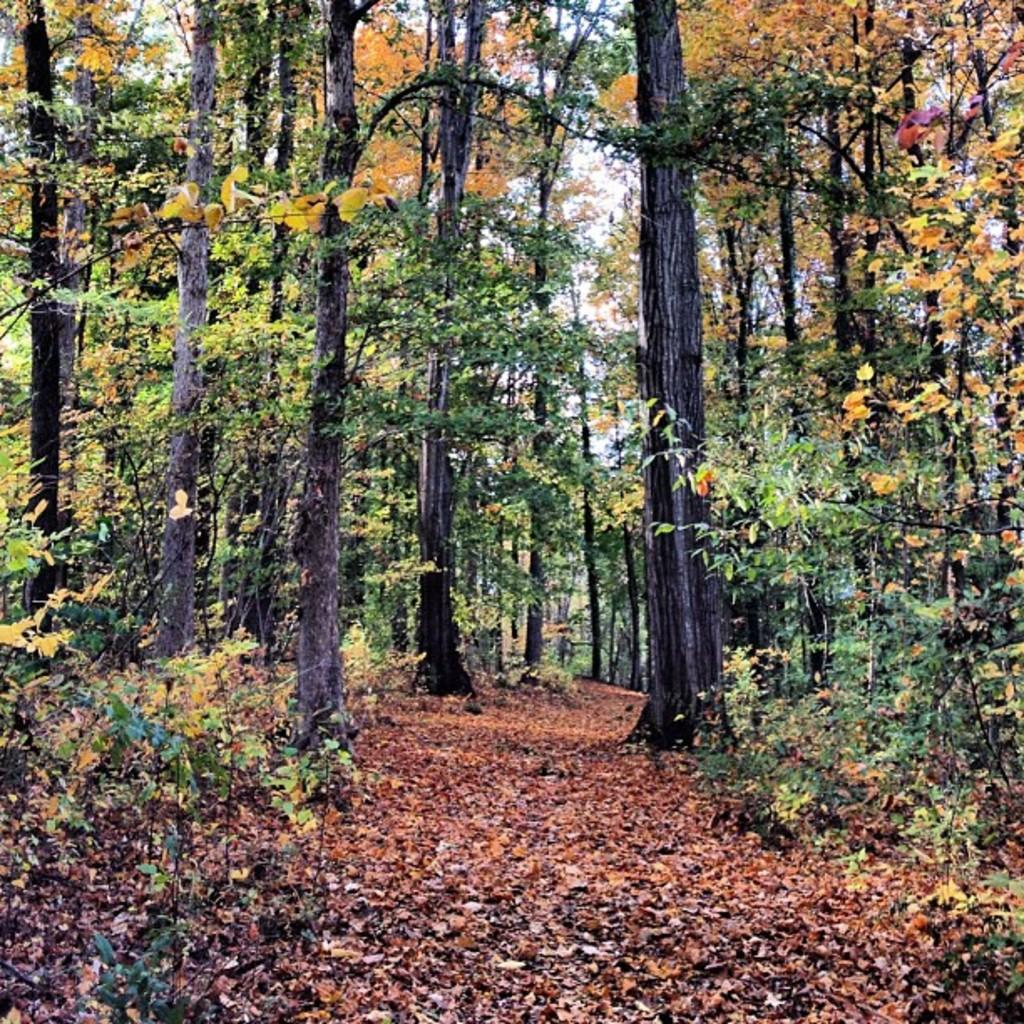What type of vegetation can be seen in the image? There are trees in the image. What is visible at the top of the image? The sky is visible at the top of the image. What type of sweater is the tree wearing in the image? There are no sweaters present in the image, as trees are not capable of wearing clothing. 